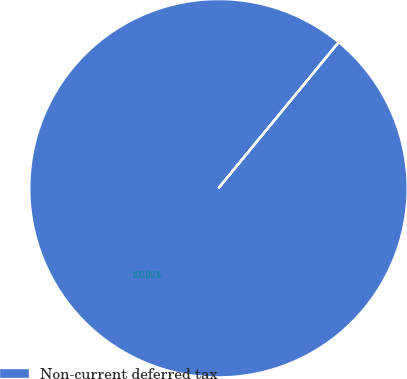<chart> <loc_0><loc_0><loc_500><loc_500><pie_chart><fcel>Non-current deferred tax<nl><fcel>100.0%<nl></chart> 